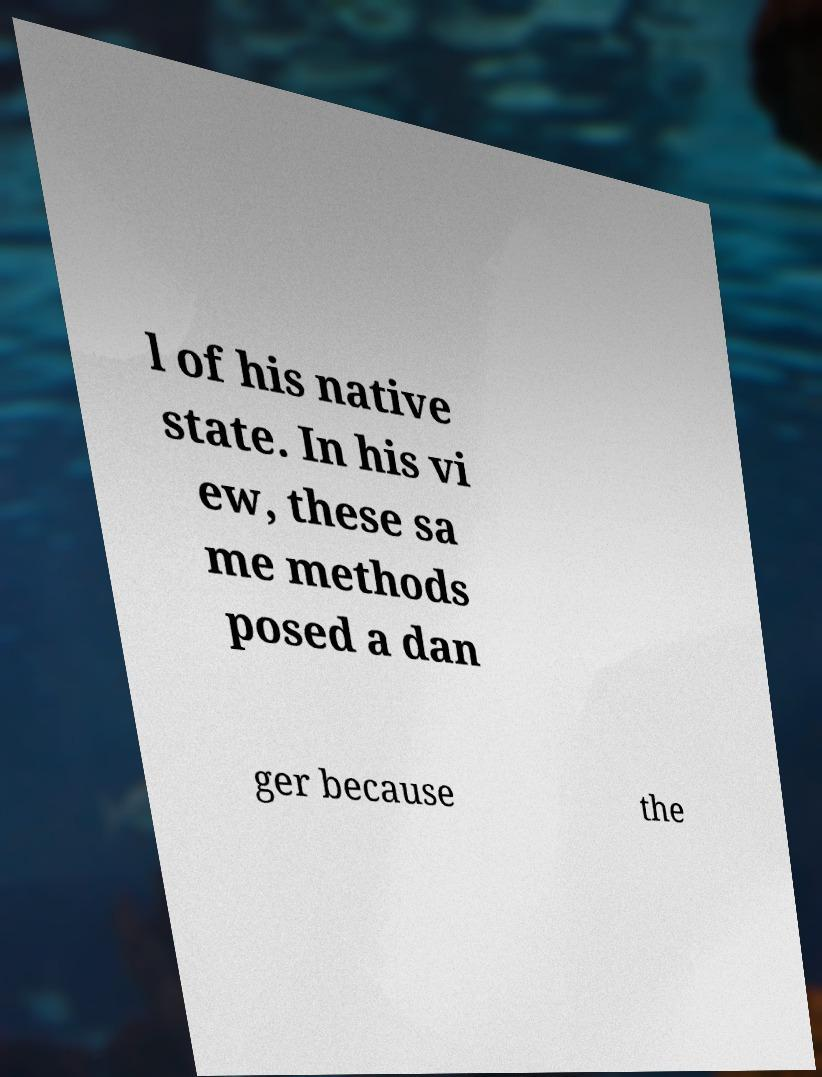Can you read and provide the text displayed in the image?This photo seems to have some interesting text. Can you extract and type it out for me? l of his native state. In his vi ew, these sa me methods posed a dan ger because the 